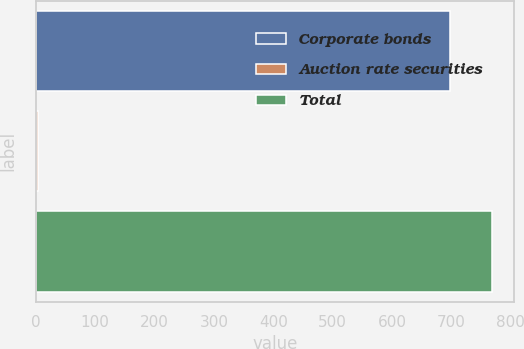Convert chart to OTSL. <chart><loc_0><loc_0><loc_500><loc_500><bar_chart><fcel>Corporate bonds<fcel>Auction rate securities<fcel>Total<nl><fcel>698.1<fcel>3.94<fcel>767.52<nl></chart> 